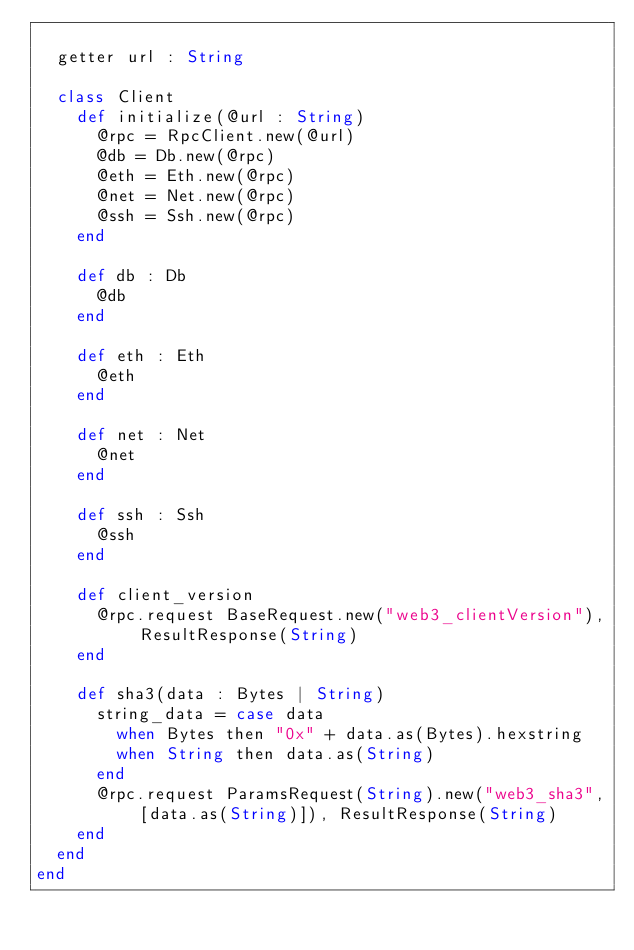<code> <loc_0><loc_0><loc_500><loc_500><_Crystal_>
  getter url : String

  class Client
    def initialize(@url : String)
      @rpc = RpcClient.new(@url)
      @db = Db.new(@rpc)
      @eth = Eth.new(@rpc)
      @net = Net.new(@rpc)
      @ssh = Ssh.new(@rpc)
    end

    def db : Db
      @db
    end

    def eth : Eth
      @eth
    end

    def net : Net
      @net
    end

    def ssh : Ssh
      @ssh
    end

    def client_version
      @rpc.request BaseRequest.new("web3_clientVersion"), ResultResponse(String)
    end

    def sha3(data : Bytes | String)
      string_data = case data
        when Bytes then "0x" + data.as(Bytes).hexstring
        when String then data.as(String)
      end
      @rpc.request ParamsRequest(String).new("web3_sha3", [data.as(String)]), ResultResponse(String)
    end
  end
end
</code> 